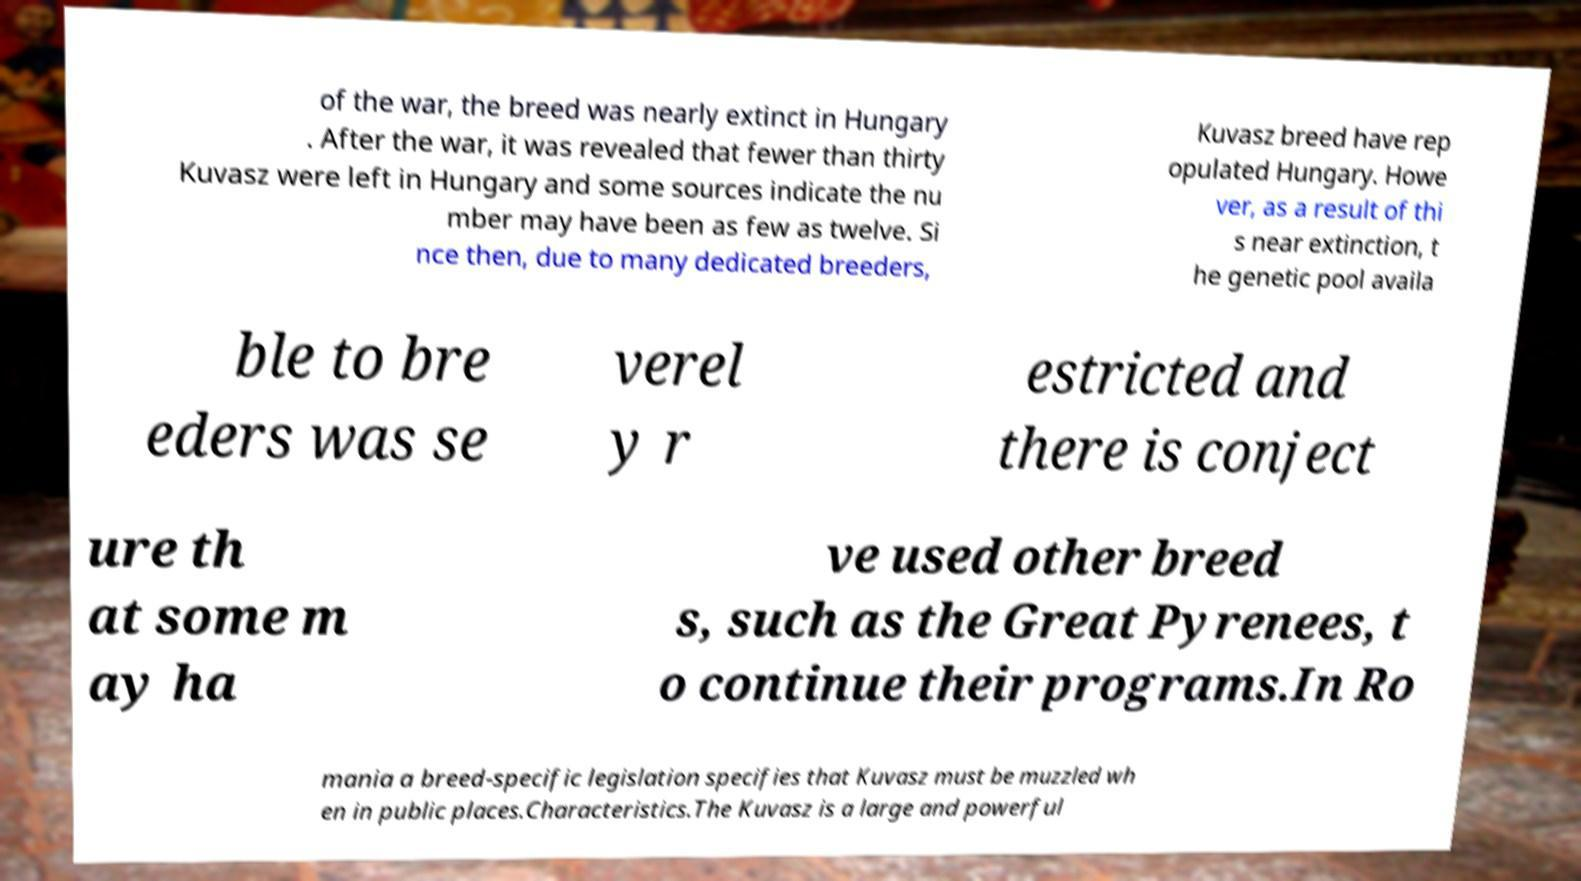Could you extract and type out the text from this image? of the war, the breed was nearly extinct in Hungary . After the war, it was revealed that fewer than thirty Kuvasz were left in Hungary and some sources indicate the nu mber may have been as few as twelve. Si nce then, due to many dedicated breeders, Kuvasz breed have rep opulated Hungary. Howe ver, as a result of thi s near extinction, t he genetic pool availa ble to bre eders was se verel y r estricted and there is conject ure th at some m ay ha ve used other breed s, such as the Great Pyrenees, t o continue their programs.In Ro mania a breed-specific legislation specifies that Kuvasz must be muzzled wh en in public places.Characteristics.The Kuvasz is a large and powerful 